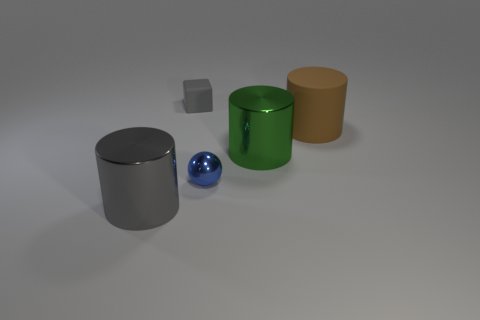Add 5 tiny gray balls. How many objects exist? 10 Subtract all gray cylinders. How many cylinders are left? 2 Subtract all cylinders. How many objects are left? 2 Subtract 1 blocks. How many blocks are left? 0 Add 5 small metallic spheres. How many small metallic spheres are left? 6 Add 1 small shiny things. How many small shiny things exist? 2 Subtract all brown cylinders. How many cylinders are left? 2 Subtract 0 cyan cubes. How many objects are left? 5 Subtract all gray balls. Subtract all brown cylinders. How many balls are left? 1 Subtract all tiny rubber things. Subtract all green cylinders. How many objects are left? 3 